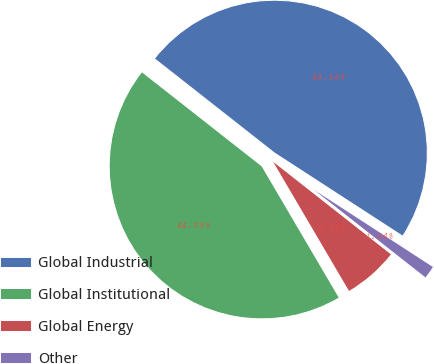Convert chart. <chart><loc_0><loc_0><loc_500><loc_500><pie_chart><fcel>Global Industrial<fcel>Global Institutional<fcel>Global Energy<fcel>Other<nl><fcel>48.56%<fcel>44.05%<fcel>5.95%<fcel>1.44%<nl></chart> 